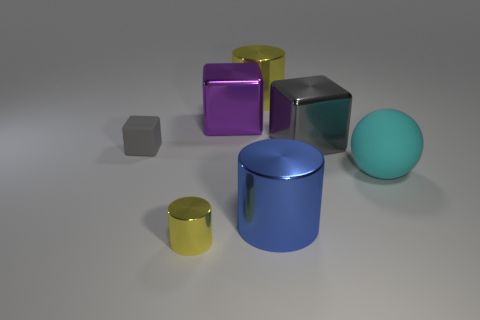What shape is the big object that is the same material as the tiny cube?
Your response must be concise. Sphere. How many other objects are there of the same shape as the big blue thing?
Make the answer very short. 2. What is the shape of the gray object on the left side of the yellow cylinder on the left side of the yellow metal thing behind the gray shiny cube?
Keep it short and to the point. Cube. How many cylinders are big cyan objects or small green things?
Ensure brevity in your answer.  0. There is a cylinder to the left of the big purple cube; are there any matte cubes that are in front of it?
Your answer should be compact. No. Is there anything else that has the same material as the big cyan thing?
Your answer should be very brief. Yes. Do the small shiny thing and the large shiny thing to the right of the large blue shiny cylinder have the same shape?
Make the answer very short. No. How many other objects are the same size as the gray metallic cube?
Give a very brief answer. 4. What number of gray things are tiny rubber blocks or rubber objects?
Provide a succinct answer. 1. How many large objects are both behind the big cyan sphere and right of the large blue metal object?
Your response must be concise. 1. 